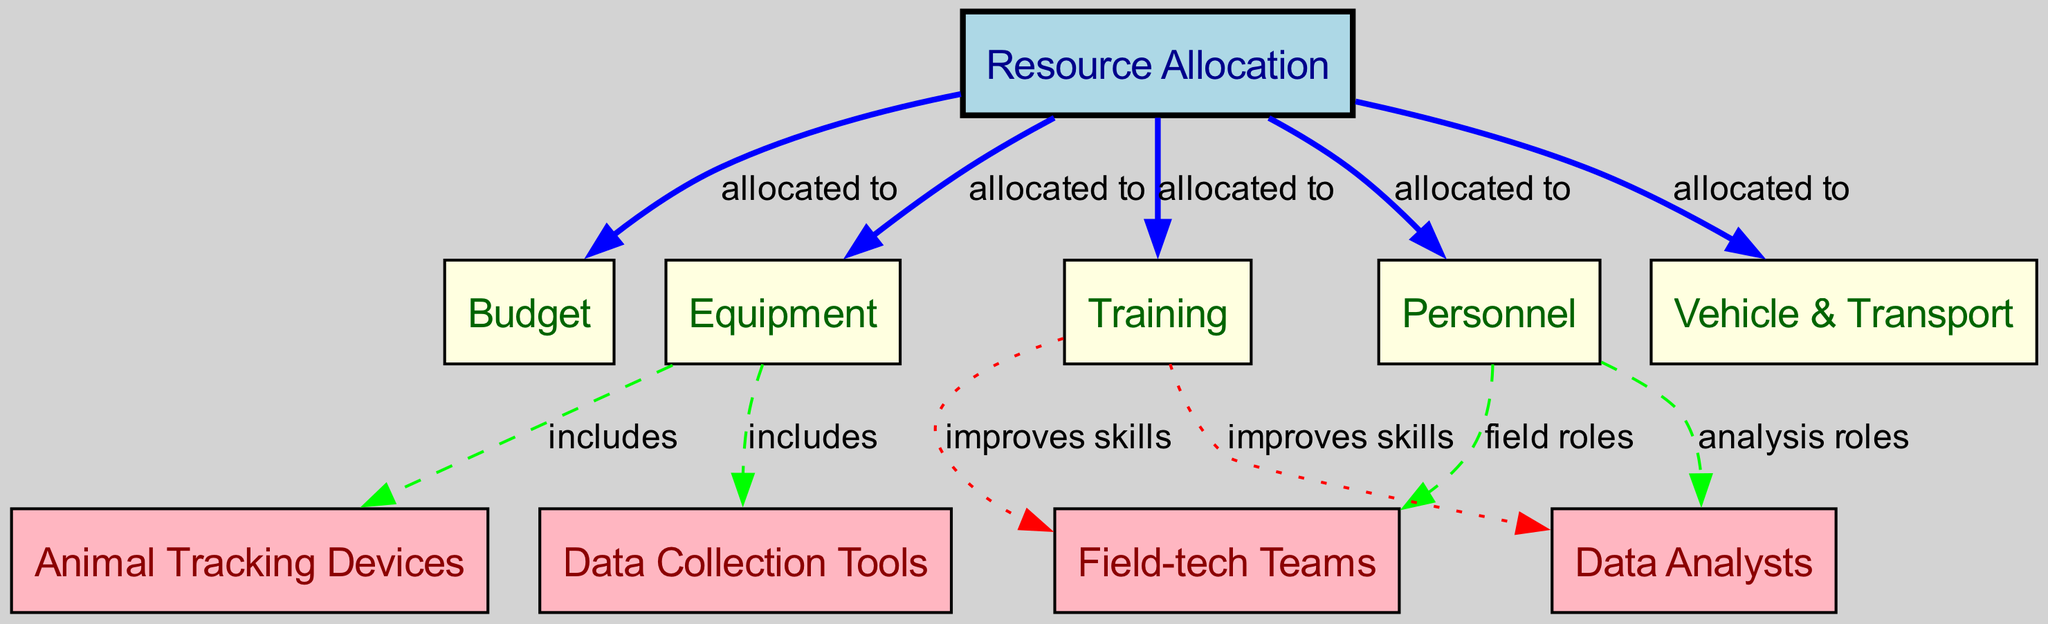What is the primary focus of the diagram? The diagram focuses on "Resource Allocation" for tracking and data collection efforts, as indicated by the main node labeled "Resource Allocation".
Answer: Resource Allocation How many nodes are present in the diagram? By counting the number of nodes listed, there are a total of 10 nodes in the diagram.
Answer: 10 What resources are allocated to personnel? The diagram shows that "Budget", "Equipment", "Training", and "Vehicle & Transport" are all allocated to "Personnel".
Answer: Budget, Equipment, Training, Vehicle & Transport Which node is linked to animal tracking devices? The node "Animal Tracking Devices" is linked to the "Equipment" node, indicated by the edge labeled "includes".
Answer: Equipment How many resources are allocated directly from the main node? There are five resources allocated from "Resource Allocation", specifically "Budget", "Equipment", "Personnel", "Training", and "Vehicle & Transport".
Answer: 5 Which types of teams are connected to personnel? The nodes directly connected to "Personnel" are "Field-tech Teams" and "Data Analysts", linked through "field roles" and "analysis roles", respectively.
Answer: Field-tech Teams, Data Analysts How does training benefit the teams? The diagram indicates that "Training" improves skills for both "Field-tech Teams" and "Data Analysts", as shown by the edges leading to these nodes.
Answer: Improves skills What color represents the main focus node? The main focus node "Resource Allocation" is represented in light blue, differentiating it from the other nodes.
Answer: Light blue Which two node types are involved in data collection? The nodes involved in data collection are "Animal Tracking Devices" and "Data Collection Tools". These nodes are included under the "Equipment" node in the diagram.
Answer: Animal Tracking Devices, Data Collection Tools Which edge style is used for the relationship between equipment and its included items? The relationship between "Equipment" and its included items, "Animal Tracking Devices" and "Data Collection Tools", is represented with dashed edges in the diagram.
Answer: Dashed edges 